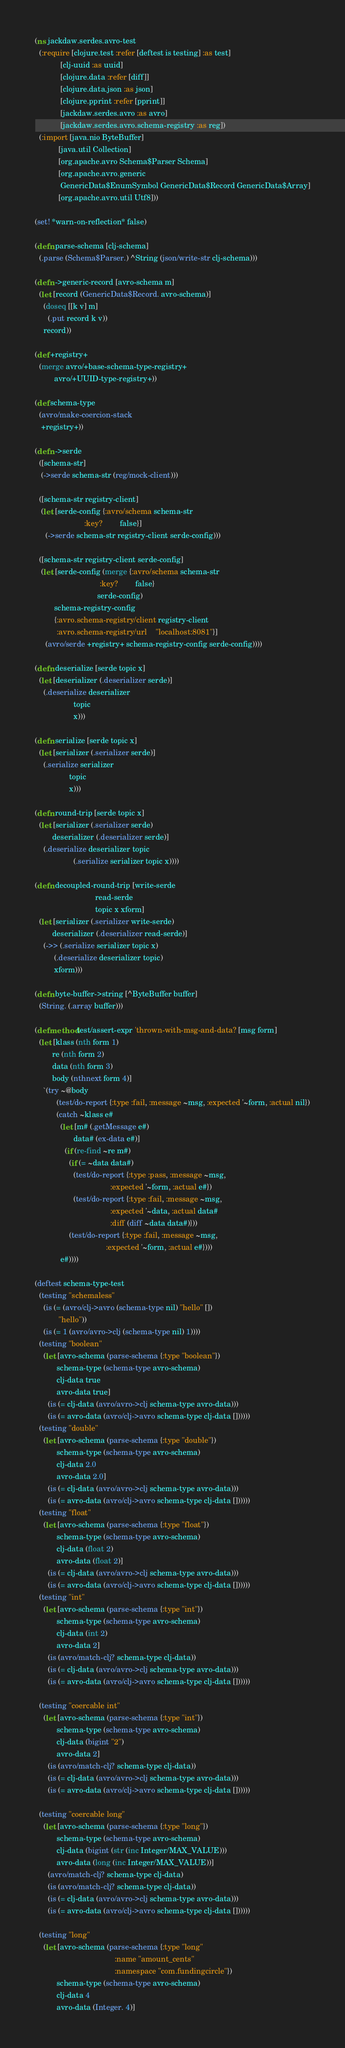Convert code to text. <code><loc_0><loc_0><loc_500><loc_500><_Clojure_>(ns jackdaw.serdes.avro-test
  (:require [clojure.test :refer [deftest is testing] :as test]
            [clj-uuid :as uuid]
            [clojure.data :refer [diff]]
            [clojure.data.json :as json]
            [clojure.pprint :refer [pprint]]
            [jackdaw.serdes.avro :as avro]
            [jackdaw.serdes.avro.schema-registry :as reg])
  (:import [java.nio ByteBuffer]
           [java.util Collection]
           [org.apache.avro Schema$Parser Schema]
           [org.apache.avro.generic
            GenericData$EnumSymbol GenericData$Record GenericData$Array]
           [org.apache.avro.util Utf8]))

(set! *warn-on-reflection* false)

(defn parse-schema [clj-schema]
  (.parse (Schema$Parser.) ^String (json/write-str clj-schema)))

(defn ->generic-record [avro-schema m]
  (let [record (GenericData$Record. avro-schema)]
    (doseq [[k v] m]
      (.put record k v))
    record))

(def +registry+
  (merge avro/+base-schema-type-registry+
         avro/+UUID-type-registry+))

(def schema-type
  (avro/make-coercion-stack
   +registry+))

(defn ->serde
  ([schema-str]
   (->serde schema-str (reg/mock-client)))

  ([schema-str registry-client]
   (let [serde-config {:avro/schema schema-str
                       :key?        false}]
     (->serde schema-str registry-client serde-config)))

  ([schema-str registry-client serde-config]
   (let [serde-config (merge {:avro/schema schema-str
                              :key?        false}
                             serde-config)
         schema-registry-config
         {:avro.schema-registry/client registry-client
          :avro.schema-registry/url    "localhost:8081"}]
     (avro/serde +registry+ schema-registry-config serde-config))))

(defn deserialize [serde topic x]
  (let [deserializer (.deserializer serde)]
    (.deserialize deserializer
                  topic
                  x)))

(defn serialize [serde topic x]
  (let [serializer (.serializer serde)]
    (.serialize serializer
                topic
                x)))

(defn round-trip [serde topic x]
  (let [serializer (.serializer serde)
        deserializer (.deserializer serde)]
    (.deserialize deserializer topic
                  (.serialize serializer topic x))))

(defn decoupled-round-trip [write-serde
                            read-serde
                            topic x xform]
  (let [serializer (.serializer write-serde)
        deserializer (.deserializer read-serde)]
    (->> (.serialize serializer topic x)
         (.deserialize deserializer topic)
         xform)))

(defn byte-buffer->string [^ByteBuffer buffer]
  (String. (.array buffer)))

(defmethod test/assert-expr 'thrown-with-msg-and-data? [msg form]
  (let [klass (nth form 1)
        re (nth form 2)
        data (nth form 3)
        body (nthnext form 4)]
    `(try ~@body
          (test/do-report {:type :fail, :message ~msg, :expected '~form, :actual nil})
          (catch ~klass e#
            (let [m# (.getMessage e#)
                  data# (ex-data e#)]
              (if (re-find ~re m#)
                (if (= ~data data#)
                  (test/do-report {:type :pass, :message ~msg,
                                   :expected '~form, :actual e#})
                  (test/do-report {:type :fail, :message ~msg,
                                   :expected '~data, :actual data#
                                   :diff (diff ~data data#)}))
                (test/do-report {:type :fail, :message ~msg,
                                 :expected '~form, :actual e#})))
            e#))))

(deftest schema-type-test
  (testing "schemaless"
    (is (= (avro/clj->avro (schema-type nil) "hello" [])
           "hello"))
    (is (= 1 (avro/avro->clj (schema-type nil) 1))))
  (testing "boolean"
    (let [avro-schema (parse-schema {:type "boolean"})
          schema-type (schema-type avro-schema)
          clj-data true
          avro-data true]
      (is (= clj-data (avro/avro->clj schema-type avro-data)))
      (is (= avro-data (avro/clj->avro schema-type clj-data [])))))
  (testing "double"
    (let [avro-schema (parse-schema {:type "double"})
          schema-type (schema-type avro-schema)
          clj-data 2.0
          avro-data 2.0]
      (is (= clj-data (avro/avro->clj schema-type avro-data)))
      (is (= avro-data (avro/clj->avro schema-type clj-data [])))))
  (testing "float"
    (let [avro-schema (parse-schema {:type "float"})
          schema-type (schema-type avro-schema)
          clj-data (float 2)
          avro-data (float 2)]
      (is (= clj-data (avro/avro->clj schema-type avro-data)))
      (is (= avro-data (avro/clj->avro schema-type clj-data [])))))
  (testing "int"
    (let [avro-schema (parse-schema {:type "int"})
          schema-type (schema-type avro-schema)
          clj-data (int 2)
          avro-data 2]
      (is (avro/match-clj? schema-type clj-data))
      (is (= clj-data (avro/avro->clj schema-type avro-data)))
      (is (= avro-data (avro/clj->avro schema-type clj-data [])))))

  (testing "coercable int"
    (let [avro-schema (parse-schema {:type "int"})
          schema-type (schema-type avro-schema)
          clj-data (bigint "2")
          avro-data 2]
      (is (avro/match-clj? schema-type clj-data))
      (is (= clj-data (avro/avro->clj schema-type avro-data)))
      (is (= avro-data (avro/clj->avro schema-type clj-data [])))))

  (testing "coercable long"
    (let [avro-schema (parse-schema {:type "long"})
          schema-type (schema-type avro-schema)
          clj-data (bigint (str (inc Integer/MAX_VALUE)))
          avro-data (long (inc Integer/MAX_VALUE))]
      (avro/match-clj? schema-type clj-data)
      (is (avro/match-clj? schema-type clj-data))
      (is (= clj-data (avro/avro->clj schema-type avro-data)))
      (is (= avro-data (avro/clj->avro schema-type clj-data [])))))

  (testing "long"
    (let [avro-schema (parse-schema {:type "long"
                                     :name "amount_cents"
                                     :namespace "com.fundingcircle"})
          schema-type (schema-type avro-schema)
          clj-data 4
          avro-data (Integer. 4)]</code> 